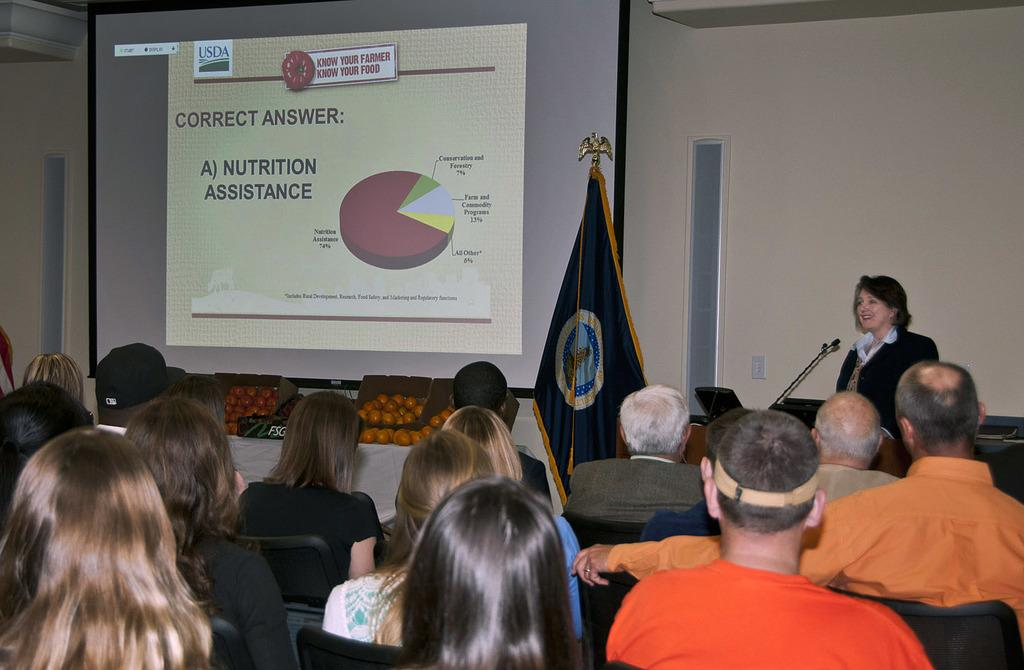What are the people in the image doing? People are sitting in the image. Can you describe the person standing in the image? The standing person is at the right back of the image and is wearing a suit. What object is present in the image that is typically used for amplifying sound? There is a microphone in the image. What type of fruit can be seen in the image? There are cartons of oranges in the image. What is displayed at the back of the image? A projector display is present at the back of the image. What type of creature is depicted in the thought bubble above the standing person's head? There is no creature depicted in the image, nor is there a thought bubble present. 